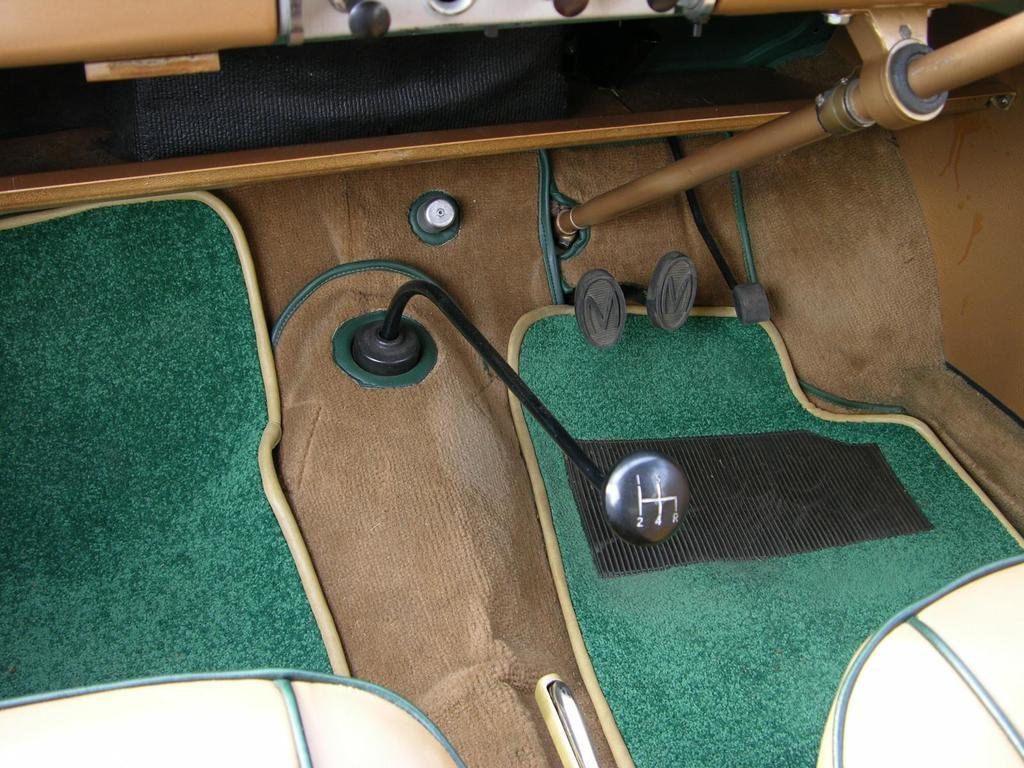What is the setting of the image? The image is inside a vehicle. What type of flooring is present in the vehicle? There are mats in the vehicle. What type of seating is available in the vehicle? There are seats in the vehicle. What is used for changing gears in the vehicle? There is a gear in the vehicle. What are the petals used for in the vehicle? There are petals for accelerator, brake, and clutch in the vehicle. What type of jam is being spread on the gear in the image? There is no jam present in the image; it is a vehicle with a gear and petals for accelerator, brake, and clutch. 